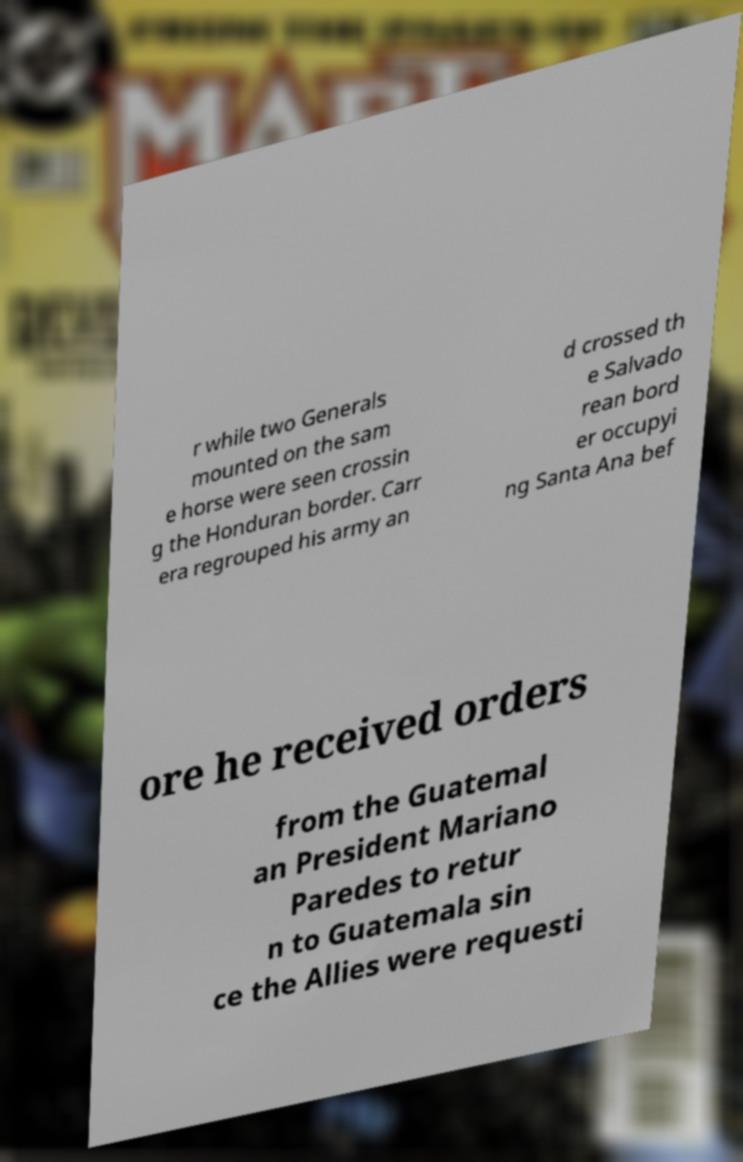Please read and relay the text visible in this image. What does it say? r while two Generals mounted on the sam e horse were seen crossin g the Honduran border. Carr era regrouped his army an d crossed th e Salvado rean bord er occupyi ng Santa Ana bef ore he received orders from the Guatemal an President Mariano Paredes to retur n to Guatemala sin ce the Allies were requesti 